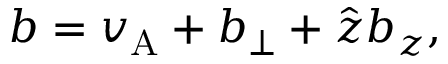Convert formula to latex. <formula><loc_0><loc_0><loc_500><loc_500>b = v _ { A } + b _ { \perp } + \hat { z } b _ { z } ,</formula> 